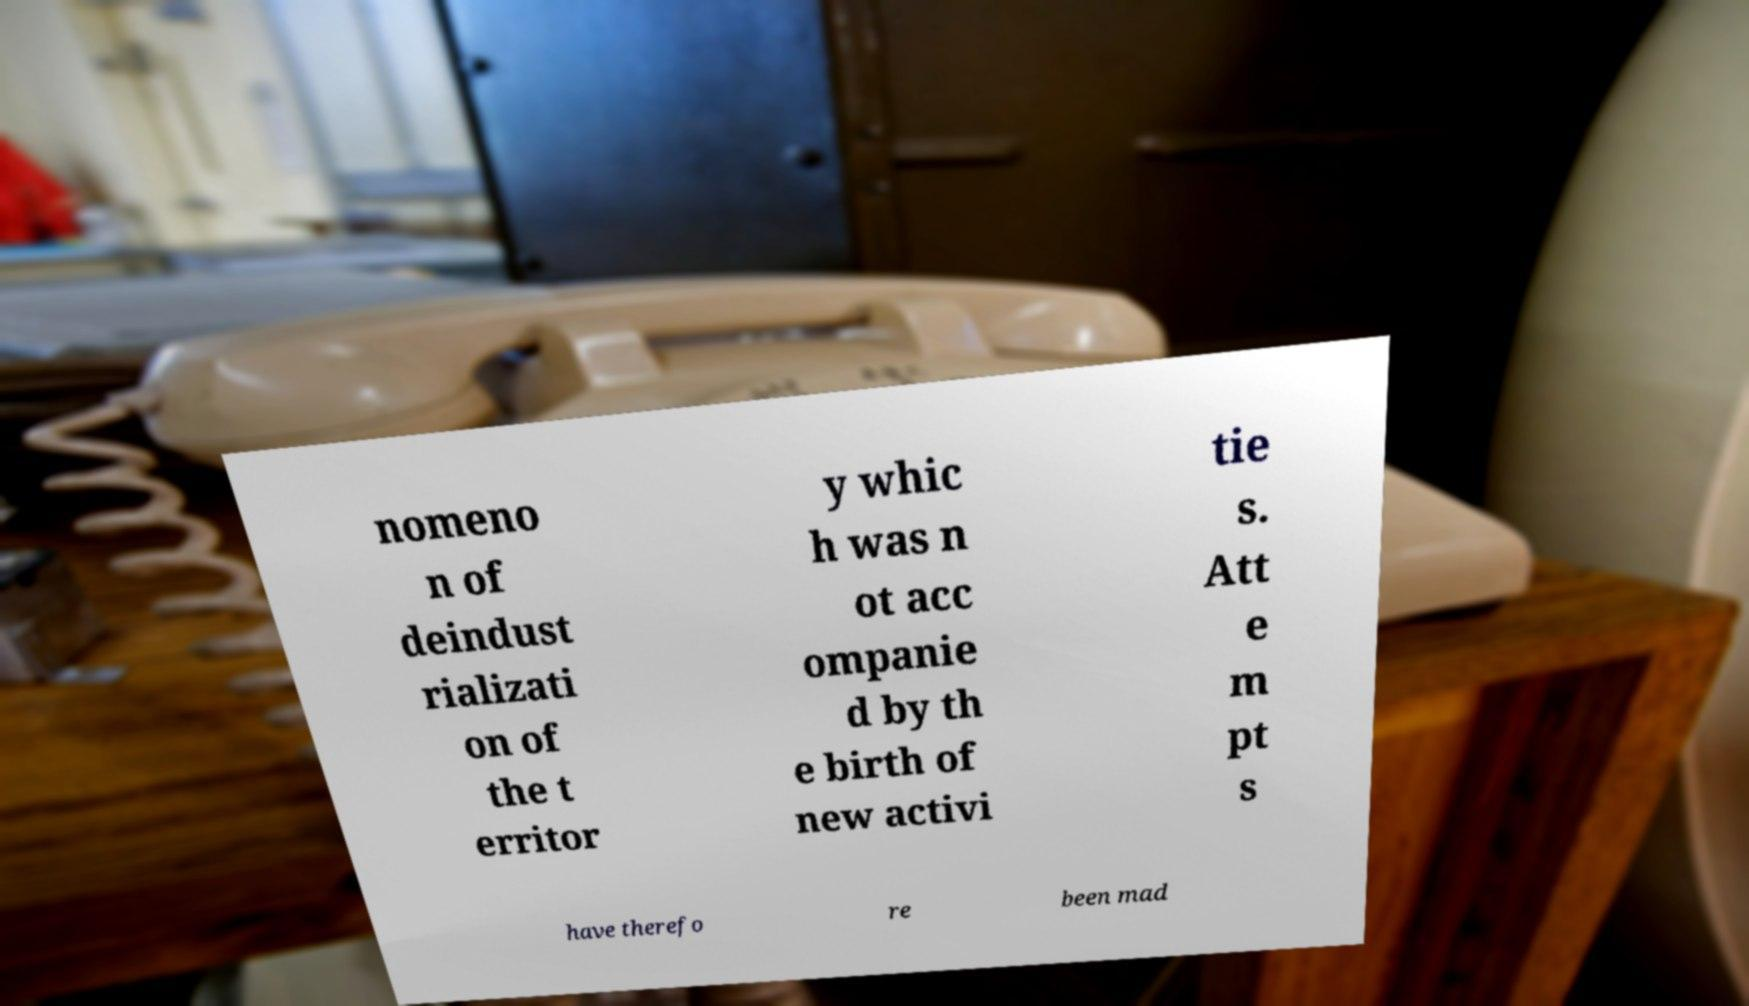I need the written content from this picture converted into text. Can you do that? nomeno n of deindust rializati on of the t erritor y whic h was n ot acc ompanie d by th e birth of new activi tie s. Att e m pt s have therefo re been mad 